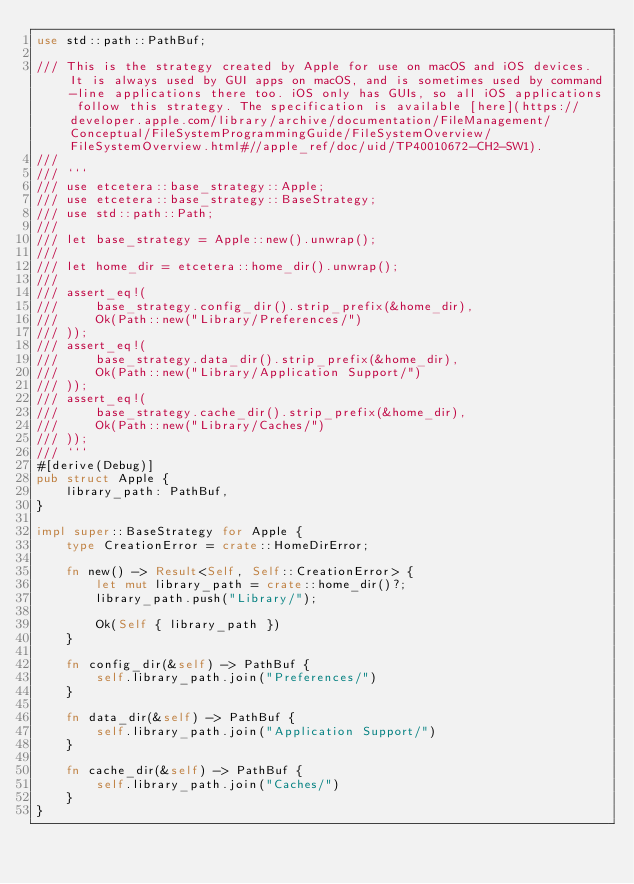<code> <loc_0><loc_0><loc_500><loc_500><_Rust_>use std::path::PathBuf;

/// This is the strategy created by Apple for use on macOS and iOS devices. It is always used by GUI apps on macOS, and is sometimes used by command-line applications there too. iOS only has GUIs, so all iOS applications follow this strategy. The specification is available [here](https://developer.apple.com/library/archive/documentation/FileManagement/Conceptual/FileSystemProgrammingGuide/FileSystemOverview/FileSystemOverview.html#//apple_ref/doc/uid/TP40010672-CH2-SW1).
///
/// ```
/// use etcetera::base_strategy::Apple;
/// use etcetera::base_strategy::BaseStrategy;
/// use std::path::Path;
///
/// let base_strategy = Apple::new().unwrap();
///
/// let home_dir = etcetera::home_dir().unwrap();
///
/// assert_eq!(
///     base_strategy.config_dir().strip_prefix(&home_dir),
///     Ok(Path::new("Library/Preferences/")
/// ));
/// assert_eq!(
///     base_strategy.data_dir().strip_prefix(&home_dir),
///     Ok(Path::new("Library/Application Support/")
/// ));
/// assert_eq!(
///     base_strategy.cache_dir().strip_prefix(&home_dir),
///     Ok(Path::new("Library/Caches/")
/// ));
/// ```
#[derive(Debug)]
pub struct Apple {
    library_path: PathBuf,
}

impl super::BaseStrategy for Apple {
    type CreationError = crate::HomeDirError;

    fn new() -> Result<Self, Self::CreationError> {
        let mut library_path = crate::home_dir()?;
        library_path.push("Library/");

        Ok(Self { library_path })
    }

    fn config_dir(&self) -> PathBuf {
        self.library_path.join("Preferences/")
    }

    fn data_dir(&self) -> PathBuf {
        self.library_path.join("Application Support/")
    }

    fn cache_dir(&self) -> PathBuf {
        self.library_path.join("Caches/")
    }
}
</code> 